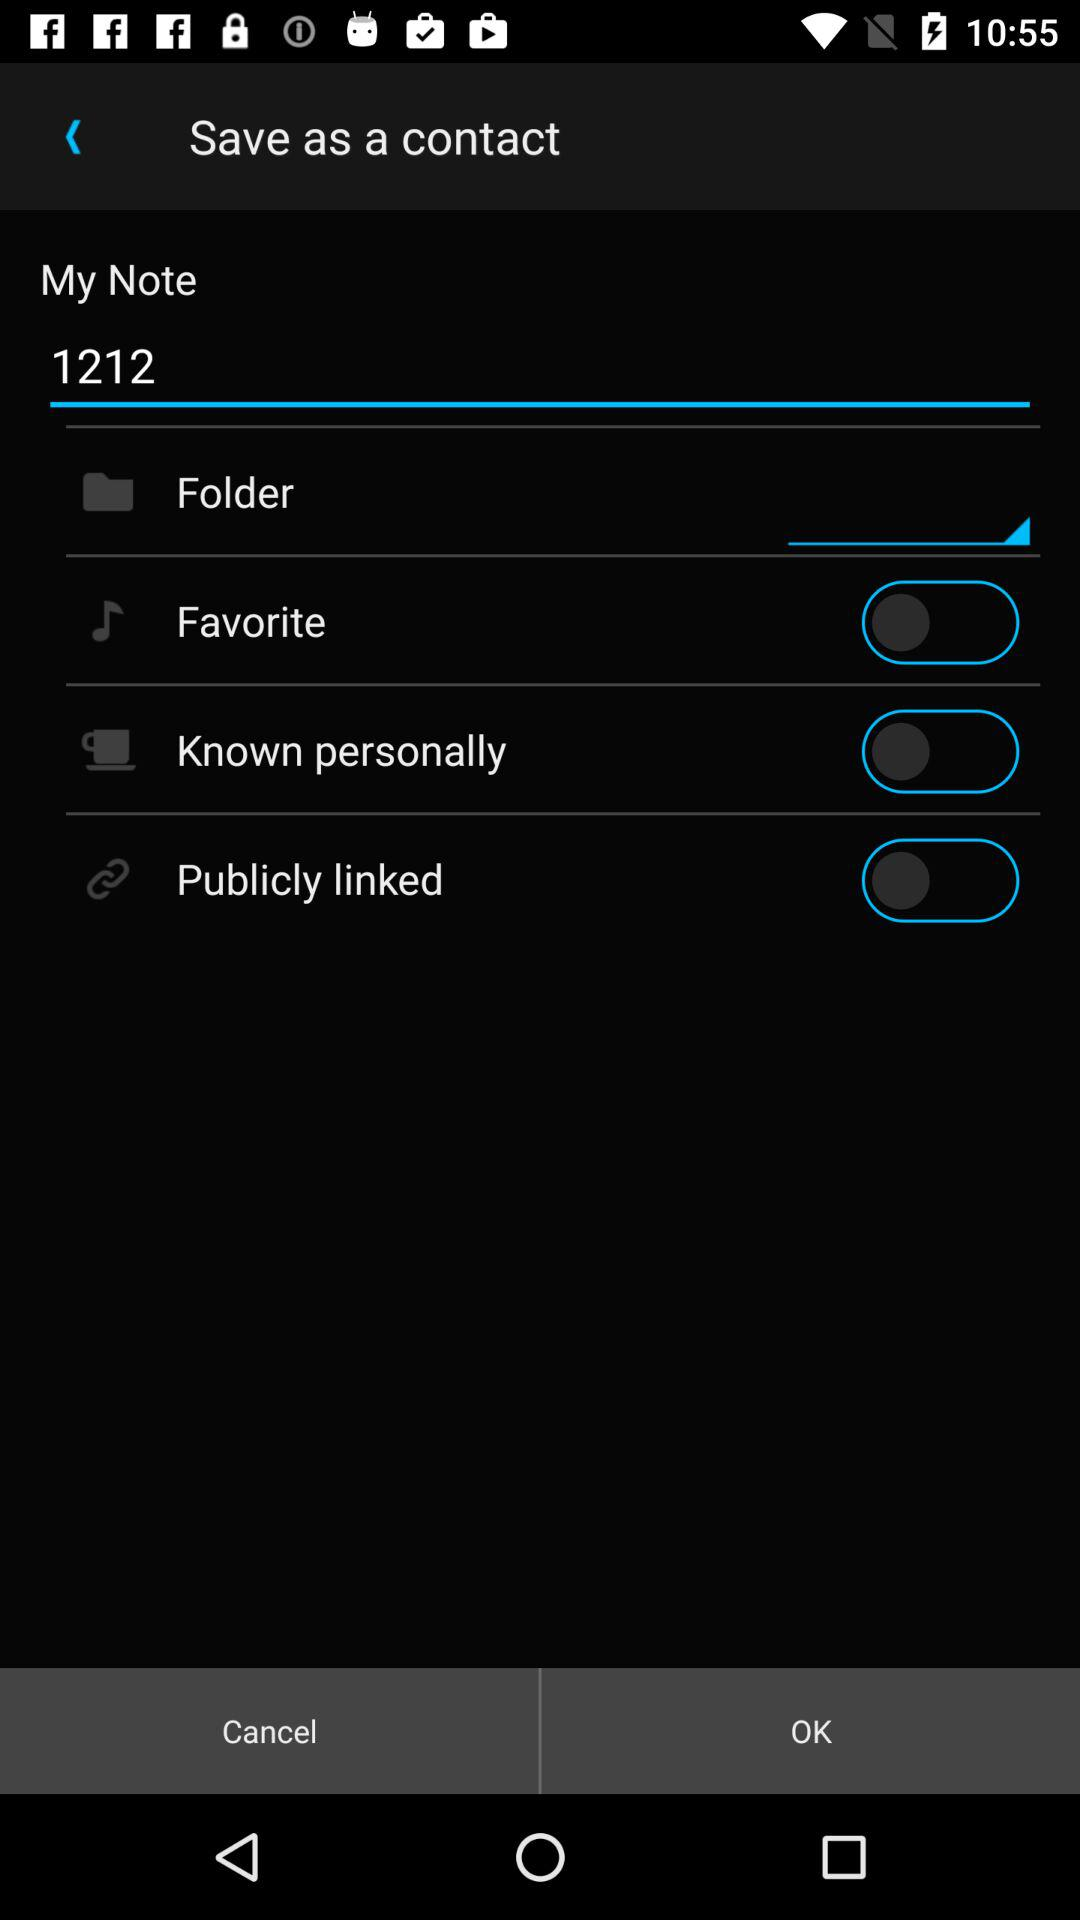What is the current status of the "Known personally"? The current status of the "Known personally" is "off". 